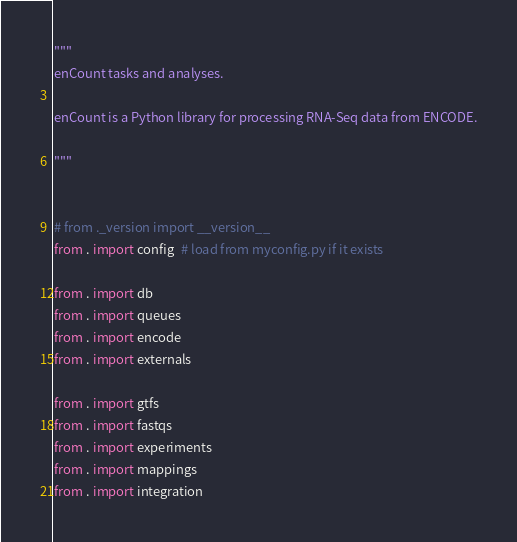<code> <loc_0><loc_0><loc_500><loc_500><_Python_>"""
enCount tasks and analyses.

enCount is a Python library for processing RNA-Seq data from ENCODE.

"""


# from ._version import __version__
from . import config  # load from myconfig.py if it exists

from . import db
from . import queues
from . import encode
from . import externals

from . import gtfs
from . import fastqs
from . import experiments
from . import mappings
from . import integration</code> 